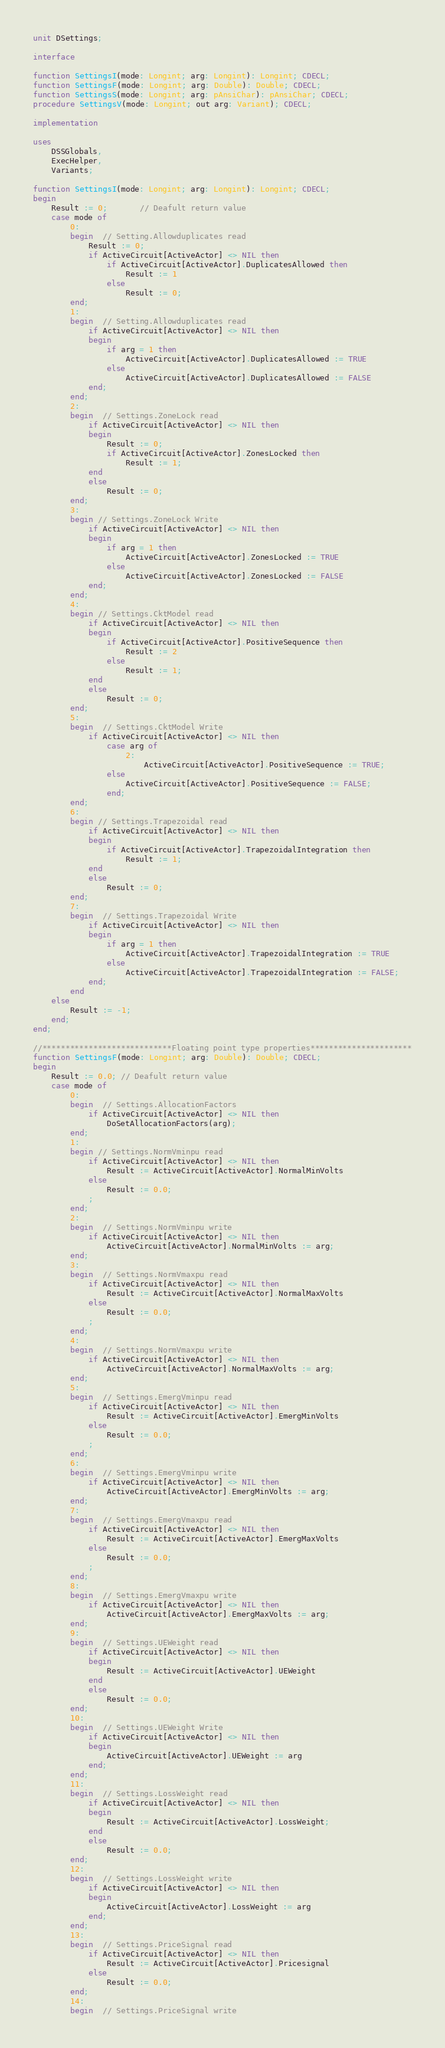<code> <loc_0><loc_0><loc_500><loc_500><_Pascal_>unit DSettings;

interface

function SettingsI(mode: Longint; arg: Longint): Longint; CDECL;
function SettingsF(mode: Longint; arg: Double): Double; CDECL;
function SettingsS(mode: Longint; arg: pAnsiChar): pAnsiChar; CDECL;
procedure SettingsV(mode: Longint; out arg: Variant); CDECL;

implementation

uses
    DSSGlobals,
    ExecHelper,
    Variants;

function SettingsI(mode: Longint; arg: Longint): Longint; CDECL;
begin
    Result := 0;       // Deafult return value
    case mode of
        0:
        begin  // Setting.Allowduplicates read
            Result := 0;
            if ActiveCircuit[ActiveActor] <> NIL then
                if ActiveCircuit[ActiveActor].DuplicatesAllowed then
                    Result := 1
                else
                    Result := 0;
        end;
        1:
        begin  // Setting.Allowduplicates read
            if ActiveCircuit[ActiveActor] <> NIL then
            begin
                if arg = 1 then
                    ActiveCircuit[ActiveActor].DuplicatesAllowed := TRUE
                else
                    ActiveCircuit[ActiveActor].DuplicatesAllowed := FALSE
            end;
        end;
        2:
        begin  // Settings.ZoneLock read
            if ActiveCircuit[ActiveActor] <> NIL then
            begin
                Result := 0;
                if ActiveCircuit[ActiveActor].ZonesLocked then
                    Result := 1;
            end
            else
                Result := 0;
        end;
        3:
        begin // Settings.ZoneLock Write
            if ActiveCircuit[ActiveActor] <> NIL then
            begin
                if arg = 1 then
                    ActiveCircuit[ActiveActor].ZonesLocked := TRUE
                else
                    ActiveCircuit[ActiveActor].ZonesLocked := FALSE
            end;
        end;
        4:
        begin // Settings.CktModel read
            if ActiveCircuit[ActiveActor] <> NIL then
            begin
                if ActiveCircuit[ActiveActor].PositiveSequence then
                    Result := 2
                else
                    Result := 1;
            end
            else
                Result := 0;
        end;
        5:
        begin  // Settings.CktModel Write
            if ActiveCircuit[ActiveActor] <> NIL then
                case arg of
                    2:
                        ActiveCircuit[ActiveActor].PositiveSequence := TRUE;
                else
                    ActiveCircuit[ActiveActor].PositiveSequence := FALSE;
                end;
        end;
        6:
        begin // Settings.Trapezoidal read
            if ActiveCircuit[ActiveActor] <> NIL then
            begin
                if ActiveCircuit[ActiveActor].TrapezoidalIntegration then
                    Result := 1;
            end
            else
                Result := 0;
        end;
        7:
        begin  // Settings.Trapezoidal Write
            if ActiveCircuit[ActiveActor] <> NIL then
            begin
                if arg = 1 then
                    ActiveCircuit[ActiveActor].TrapezoidalIntegration := TRUE
                else
                    ActiveCircuit[ActiveActor].TrapezoidalIntegration := FALSE;
            end;
        end
    else
        Result := -1;
    end;
end;

//****************************Floating point type properties**********************
function SettingsF(mode: Longint; arg: Double): Double; CDECL;
begin
    Result := 0.0; // Deafult return value
    case mode of
        0:
        begin  // Settings.AllocationFactors
            if ActiveCircuit[ActiveActor] <> NIL then
                DoSetAllocationFactors(arg);
        end;
        1:
        begin // Settings.NormVminpu read
            if ActiveCircuit[ActiveActor] <> NIL then
                Result := ActiveCircuit[ActiveActor].NormalMinVolts
            else
                Result := 0.0;
            ;
        end;
        2:
        begin  // Settings.NormVminpu write
            if ActiveCircuit[ActiveActor] <> NIL then
                ActiveCircuit[ActiveActor].NormalMinVolts := arg;
        end;
        3:
        begin  // Settings.NormVmaxpu read
            if ActiveCircuit[ActiveActor] <> NIL then
                Result := ActiveCircuit[ActiveActor].NormalMaxVolts
            else
                Result := 0.0;
            ;
        end;
        4:
        begin  // Settings.NormVmaxpu write
            if ActiveCircuit[ActiveActor] <> NIL then
                ActiveCircuit[ActiveActor].NormalMaxVolts := arg;
        end;
        5:
        begin  // Settings.EmergVminpu read
            if ActiveCircuit[ActiveActor] <> NIL then
                Result := ActiveCircuit[ActiveActor].EmergMinVolts
            else
                Result := 0.0;
            ;
        end;
        6:
        begin  // Settings.EmergVminpu write
            if ActiveCircuit[ActiveActor] <> NIL then
                ActiveCircuit[ActiveActor].EmergMinVolts := arg;
        end;
        7:
        begin  // Settings.EmergVmaxpu read
            if ActiveCircuit[ActiveActor] <> NIL then
                Result := ActiveCircuit[ActiveActor].EmergMaxVolts
            else
                Result := 0.0;
            ;
        end;
        8:
        begin  // Settings.EmergVmaxpu write
            if ActiveCircuit[ActiveActor] <> NIL then
                ActiveCircuit[ActiveActor].EmergMaxVolts := arg;
        end;
        9:
        begin  // Settings.UEWeight read
            if ActiveCircuit[ActiveActor] <> NIL then
            begin
                Result := ActiveCircuit[ActiveActor].UEWeight
            end
            else
                Result := 0.0;
        end;
        10:
        begin  // Settings.UEWeight Write
            if ActiveCircuit[ActiveActor] <> NIL then
            begin
                ActiveCircuit[ActiveActor].UEWeight := arg
            end;
        end;
        11:
        begin  // Settings.LossWeight read
            if ActiveCircuit[ActiveActor] <> NIL then
            begin
                Result := ActiveCircuit[ActiveActor].LossWeight;
            end
            else
                Result := 0.0;
        end;
        12:
        begin  // Settings.LossWeight write
            if ActiveCircuit[ActiveActor] <> NIL then
            begin
                ActiveCircuit[ActiveActor].LossWeight := arg
            end;
        end;
        13:
        begin  // Settings.PriceSignal read
            if ActiveCircuit[ActiveActor] <> NIL then
                Result := ActiveCircuit[ActiveActor].Pricesignal
            else
                Result := 0.0;
        end;
        14:
        begin  // Settings.PriceSignal write</code> 